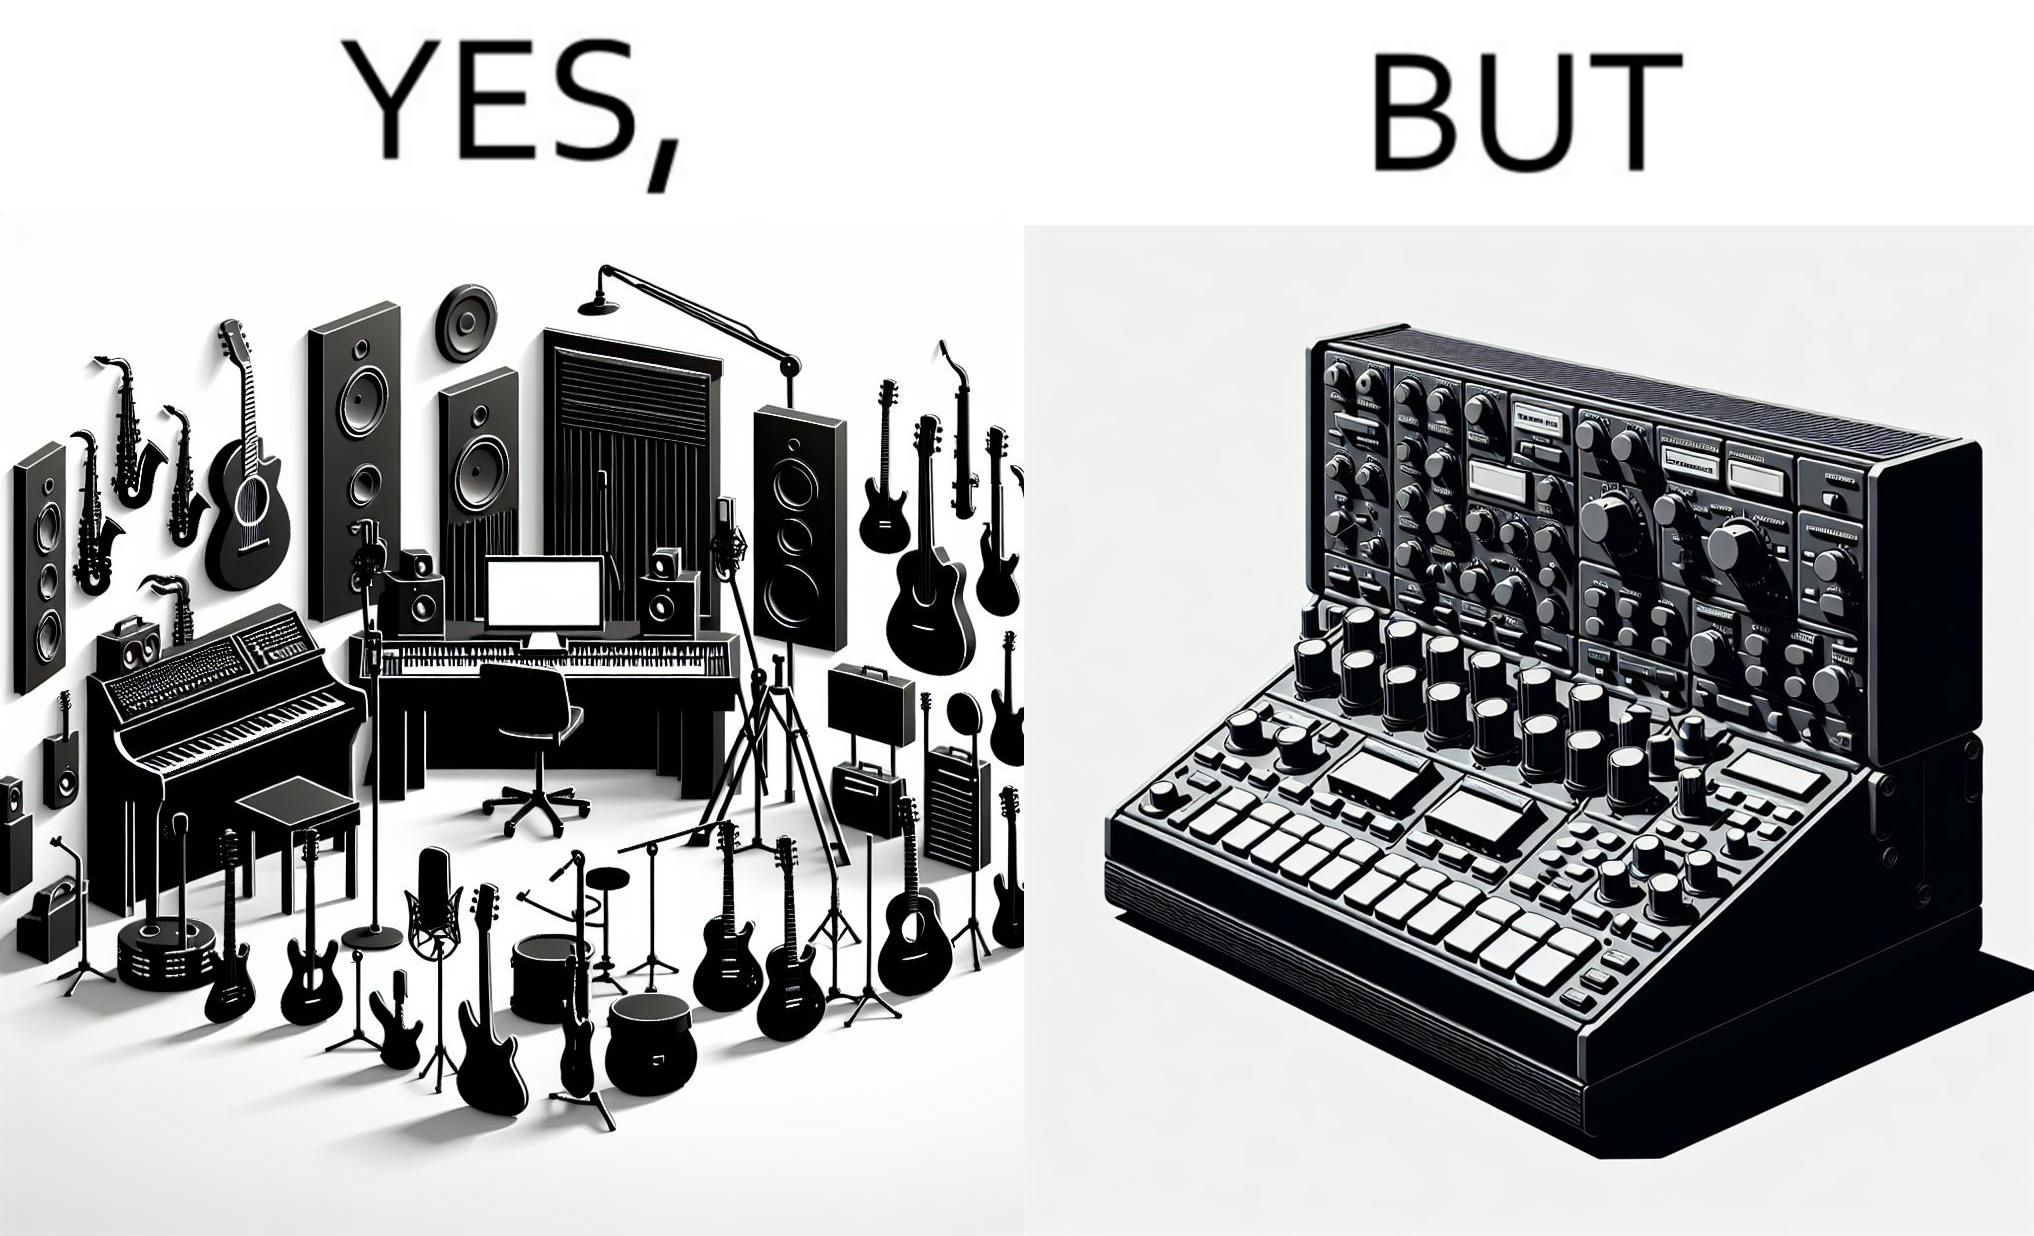What is the satirical meaning behind this image? The image overall is funny because even though people have great music studios and instruments to create and record music, they use electronic replacements of the musical instruments to achieve the task. 